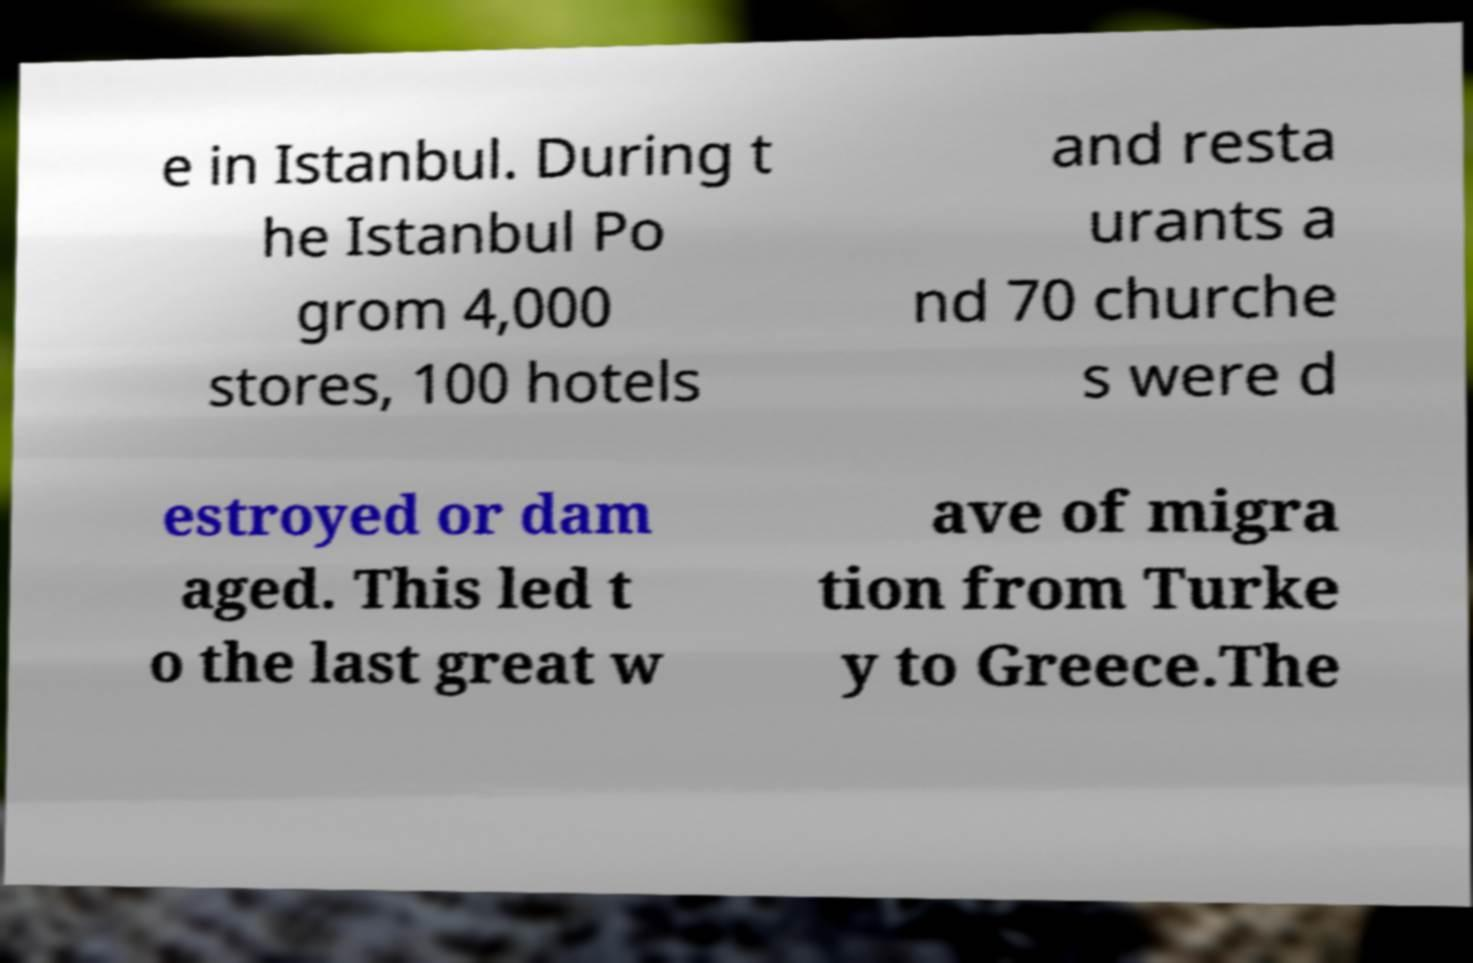I need the written content from this picture converted into text. Can you do that? e in Istanbul. During t he Istanbul Po grom 4,000 stores, 100 hotels and resta urants a nd 70 churche s were d estroyed or dam aged. This led t o the last great w ave of migra tion from Turke y to Greece.The 